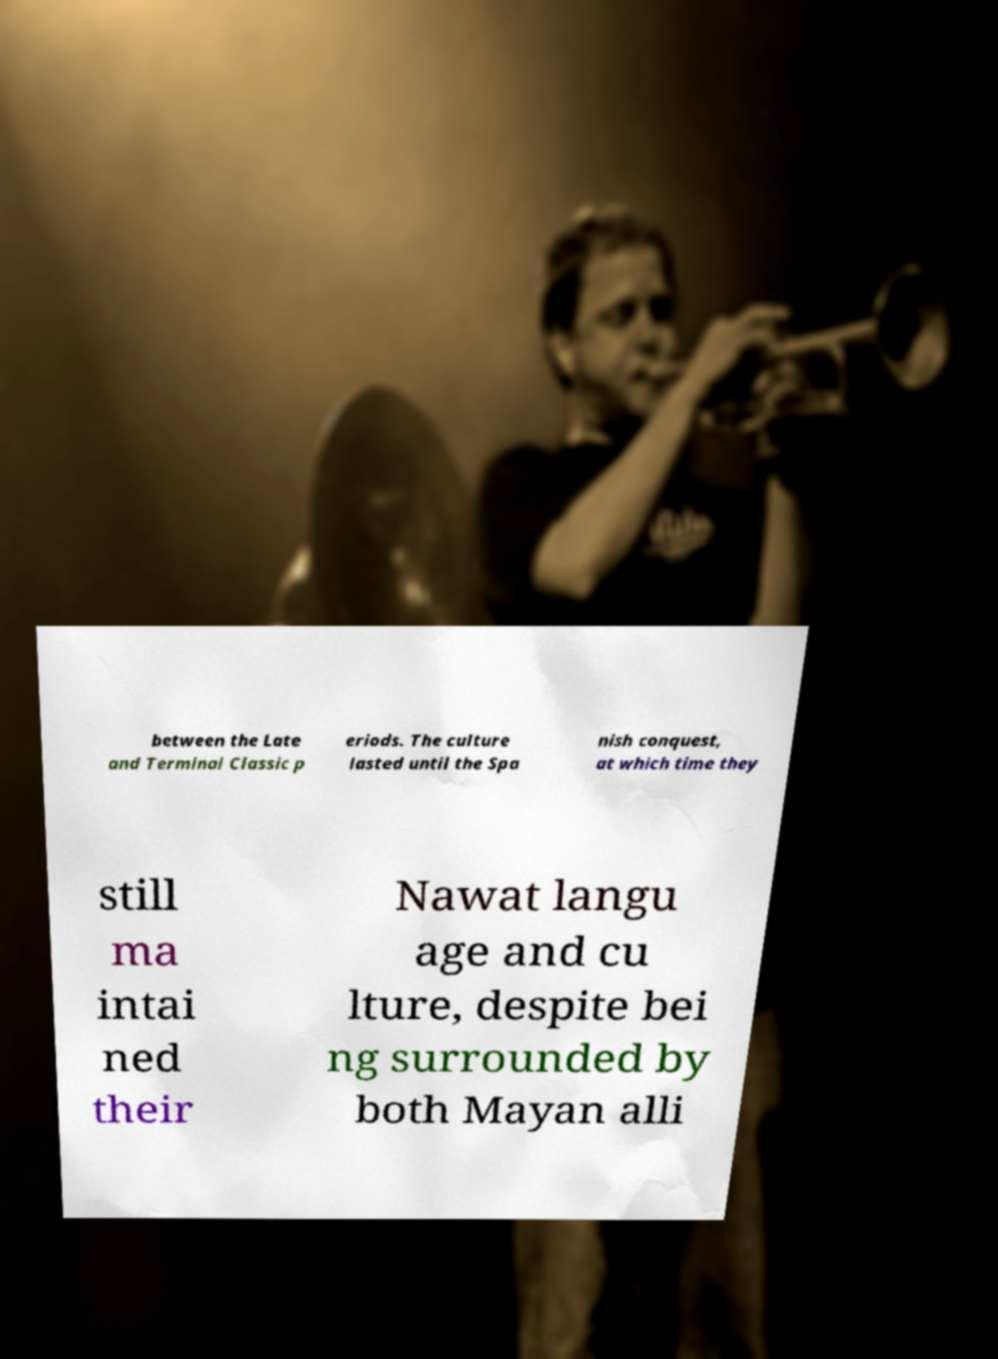Can you read and provide the text displayed in the image?This photo seems to have some interesting text. Can you extract and type it out for me? between the Late and Terminal Classic p eriods. The culture lasted until the Spa nish conquest, at which time they still ma intai ned their Nawat langu age and cu lture, despite bei ng surrounded by both Mayan alli 